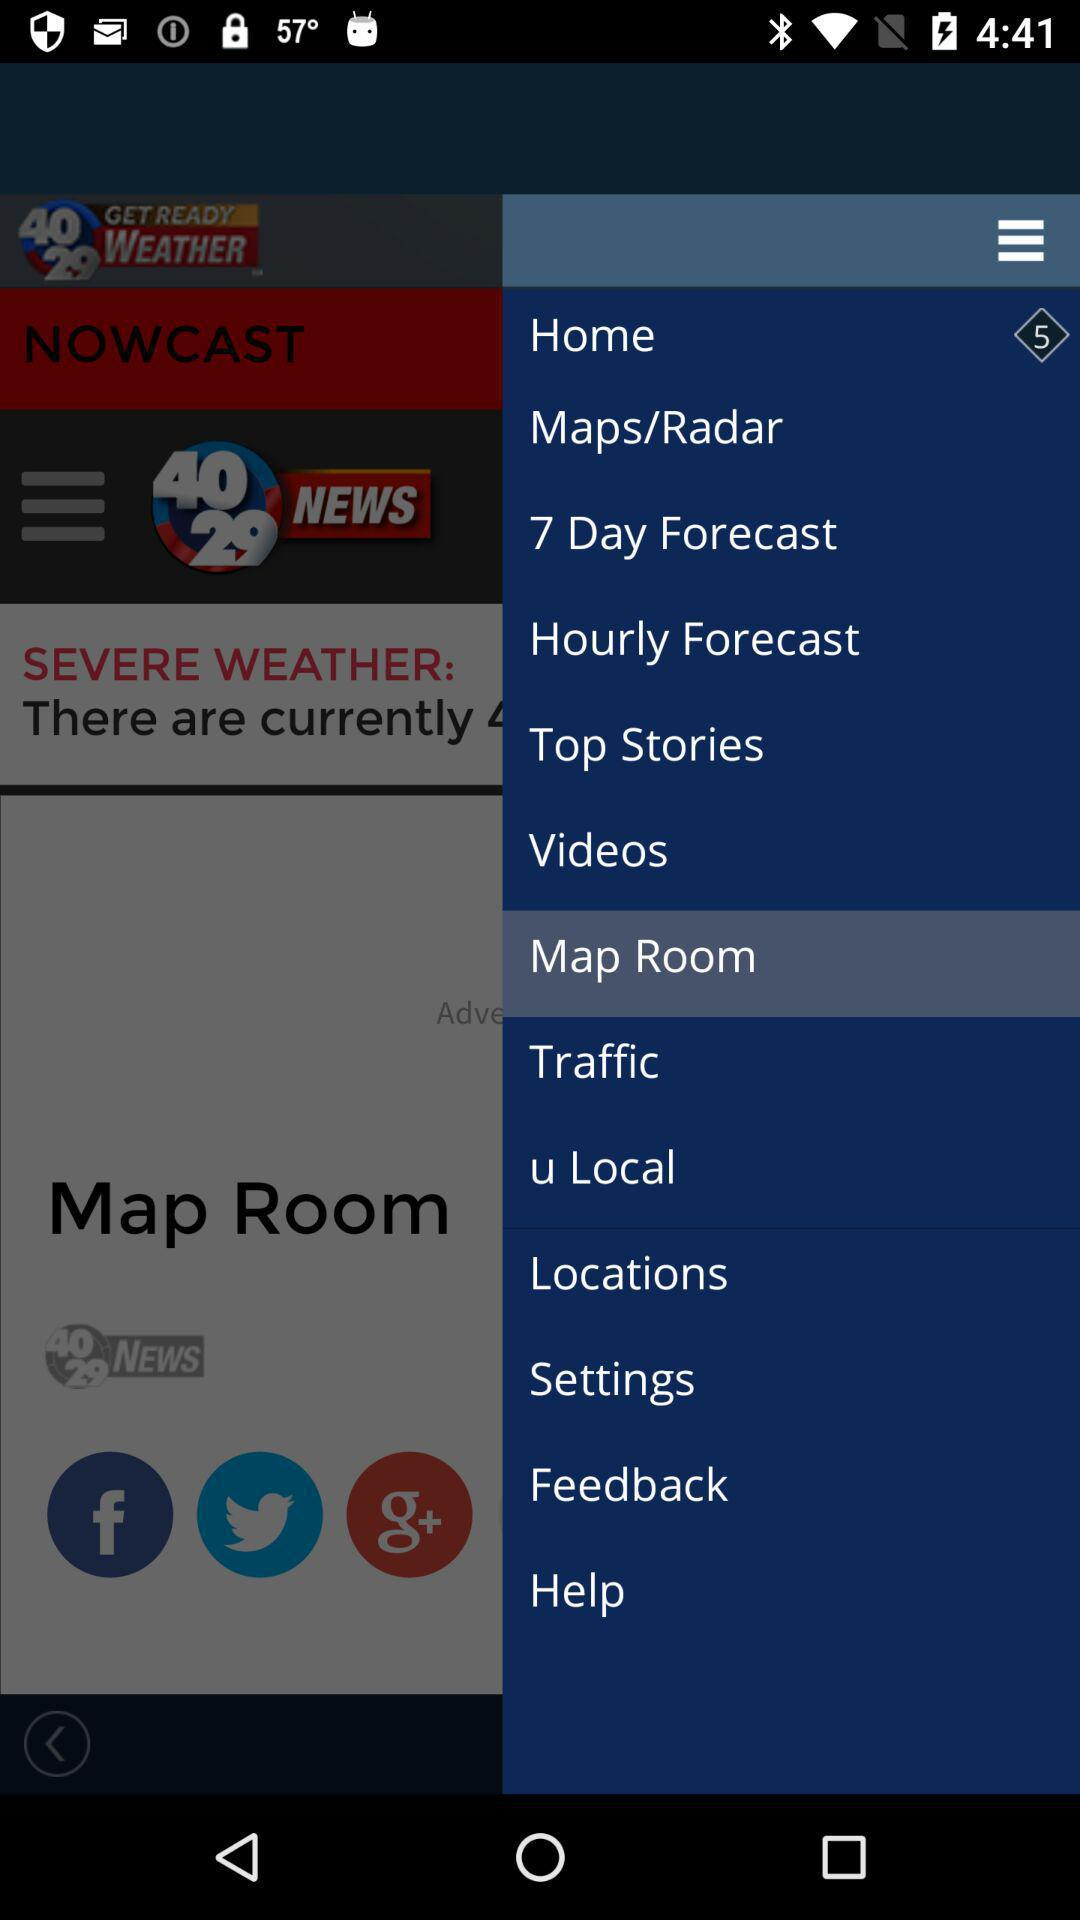Which is the selected item in the menu? The selected item in the menu is "Map Room". 